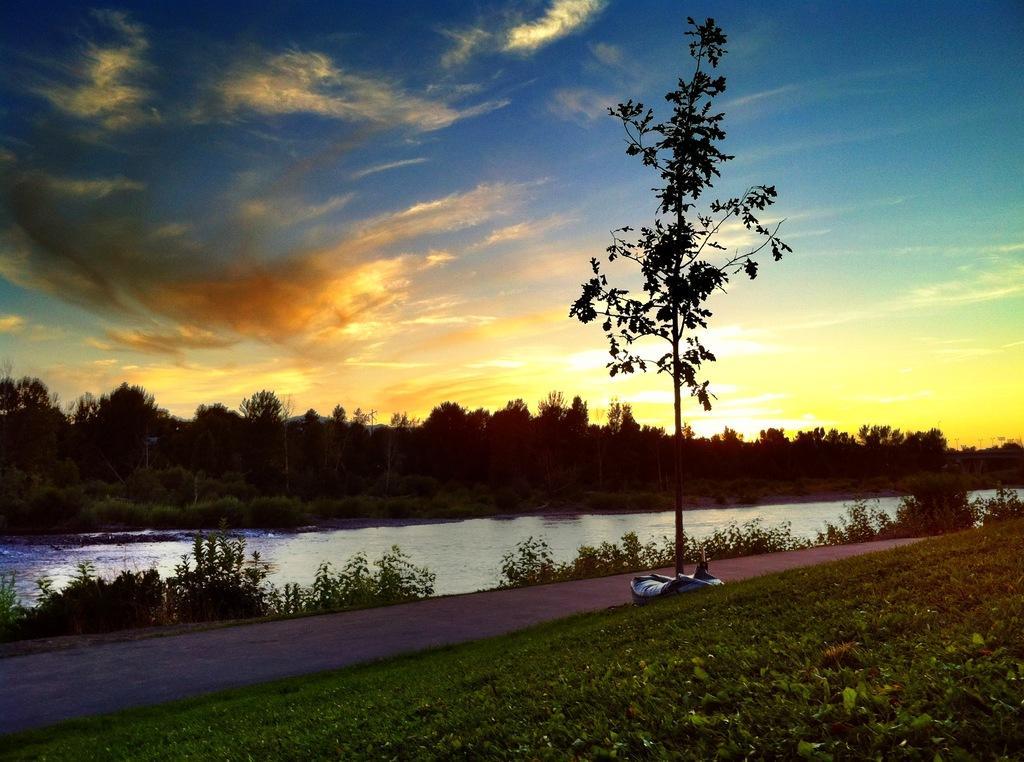Could you give a brief overview of what you see in this image? In this picture we can see an object on the path. On the right side of the path there is grass. Behind the path there is a river, trees, plants and the sky. 